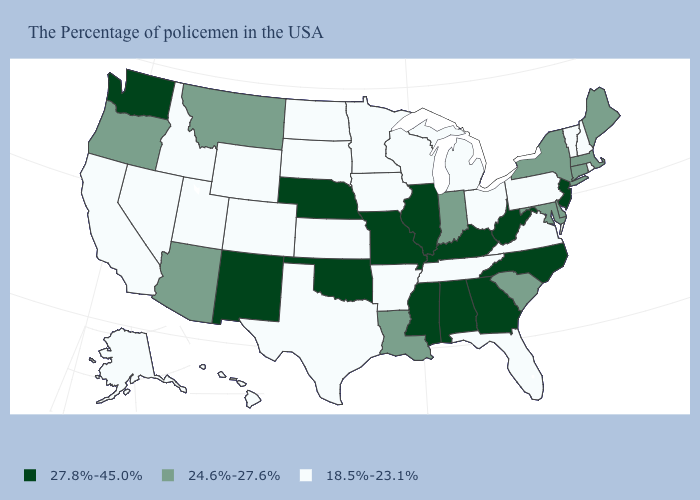Which states have the lowest value in the USA?
Answer briefly. Rhode Island, New Hampshire, Vermont, Pennsylvania, Virginia, Ohio, Florida, Michigan, Tennessee, Wisconsin, Arkansas, Minnesota, Iowa, Kansas, Texas, South Dakota, North Dakota, Wyoming, Colorado, Utah, Idaho, Nevada, California, Alaska, Hawaii. What is the value of Nebraska?
Quick response, please. 27.8%-45.0%. What is the value of New York?
Give a very brief answer. 24.6%-27.6%. Does Maine have a lower value than Rhode Island?
Keep it brief. No. Which states hav the highest value in the West?
Write a very short answer. New Mexico, Washington. Which states hav the highest value in the Northeast?
Answer briefly. New Jersey. Which states have the lowest value in the USA?
Short answer required. Rhode Island, New Hampshire, Vermont, Pennsylvania, Virginia, Ohio, Florida, Michigan, Tennessee, Wisconsin, Arkansas, Minnesota, Iowa, Kansas, Texas, South Dakota, North Dakota, Wyoming, Colorado, Utah, Idaho, Nevada, California, Alaska, Hawaii. Which states have the lowest value in the Northeast?
Write a very short answer. Rhode Island, New Hampshire, Vermont, Pennsylvania. What is the value of California?
Write a very short answer. 18.5%-23.1%. What is the lowest value in the South?
Quick response, please. 18.5%-23.1%. Does the first symbol in the legend represent the smallest category?
Quick response, please. No. Which states hav the highest value in the West?
Concise answer only. New Mexico, Washington. Name the states that have a value in the range 24.6%-27.6%?
Quick response, please. Maine, Massachusetts, Connecticut, New York, Delaware, Maryland, South Carolina, Indiana, Louisiana, Montana, Arizona, Oregon. Name the states that have a value in the range 24.6%-27.6%?
Write a very short answer. Maine, Massachusetts, Connecticut, New York, Delaware, Maryland, South Carolina, Indiana, Louisiana, Montana, Arizona, Oregon. Name the states that have a value in the range 24.6%-27.6%?
Give a very brief answer. Maine, Massachusetts, Connecticut, New York, Delaware, Maryland, South Carolina, Indiana, Louisiana, Montana, Arizona, Oregon. 